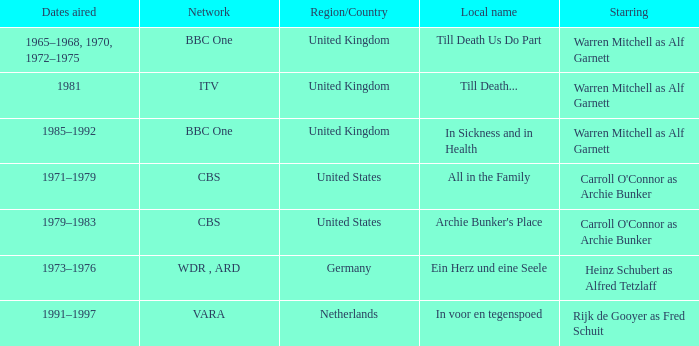Parse the table in full. {'header': ['Dates aired', 'Network', 'Region/Country', 'Local name', 'Starring'], 'rows': [['1965–1968, 1970, 1972–1975', 'BBC One', 'United Kingdom', 'Till Death Us Do Part', 'Warren Mitchell as Alf Garnett'], ['1981', 'ITV', 'United Kingdom', 'Till Death...', 'Warren Mitchell as Alf Garnett'], ['1985–1992', 'BBC One', 'United Kingdom', 'In Sickness and in Health', 'Warren Mitchell as Alf Garnett'], ['1971–1979', 'CBS', 'United States', 'All in the Family', "Carroll O'Connor as Archie Bunker"], ['1979–1983', 'CBS', 'United States', "Archie Bunker's Place", "Carroll O'Connor as Archie Bunker"], ['1973–1976', 'WDR , ARD', 'Germany', 'Ein Herz und eine Seele', 'Heinz Schubert as Alfred Tetzlaff'], ['1991–1997', 'VARA', 'Netherlands', 'In voor en tegenspoed', 'Rijk de Gooyer as Fred Schuit']]} What is the local name for the episodes that aired in 1981? Till Death... 